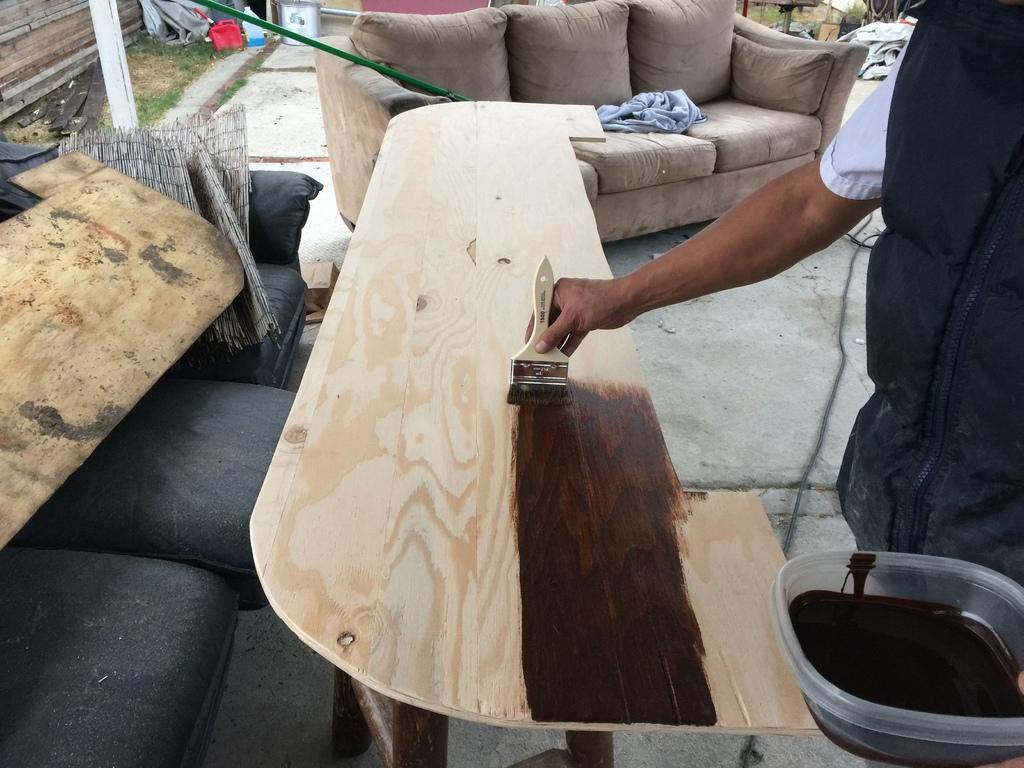What is the man in the image doing? The man is painting a wooden board. What tool is the man using to paint? The man is using a brush to paint. What is the man holding in his hand? The man is holding a bowl in his hand. What can be seen in the background of the image? There is a sofa and cans in the background of the image. How many tomatoes are on the wooden board that the man is painting? There are no tomatoes present in the image, as the man is painting a wooden board and not a scene involving tomatoes. 